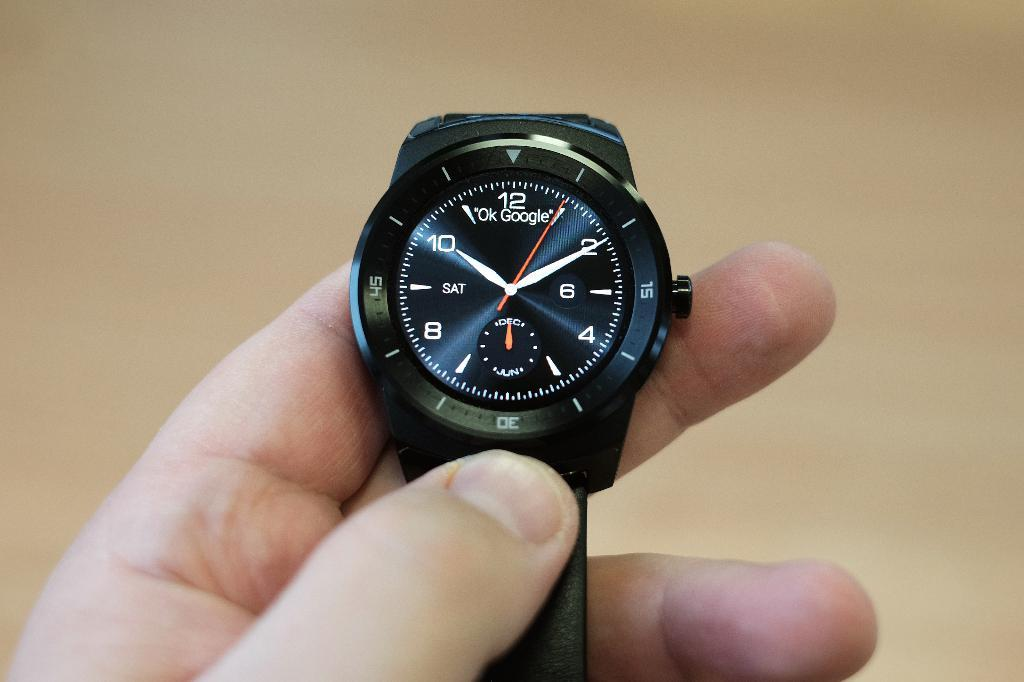<image>
Summarize the visual content of the image. A man is holding a black watch with a number 8 on it. 